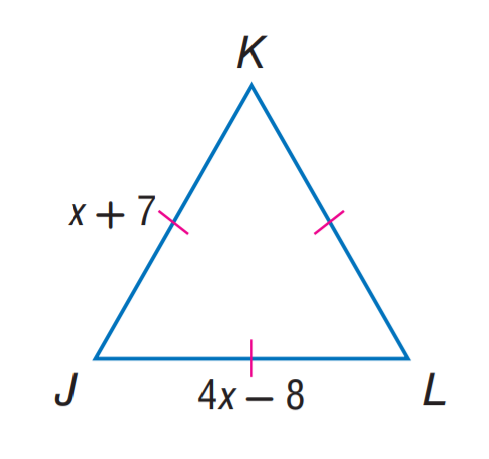Answer the mathemtical geometry problem and directly provide the correct option letter.
Question: Find J L.
Choices: A: 7 B: 8 C: 12 D: 15 C 